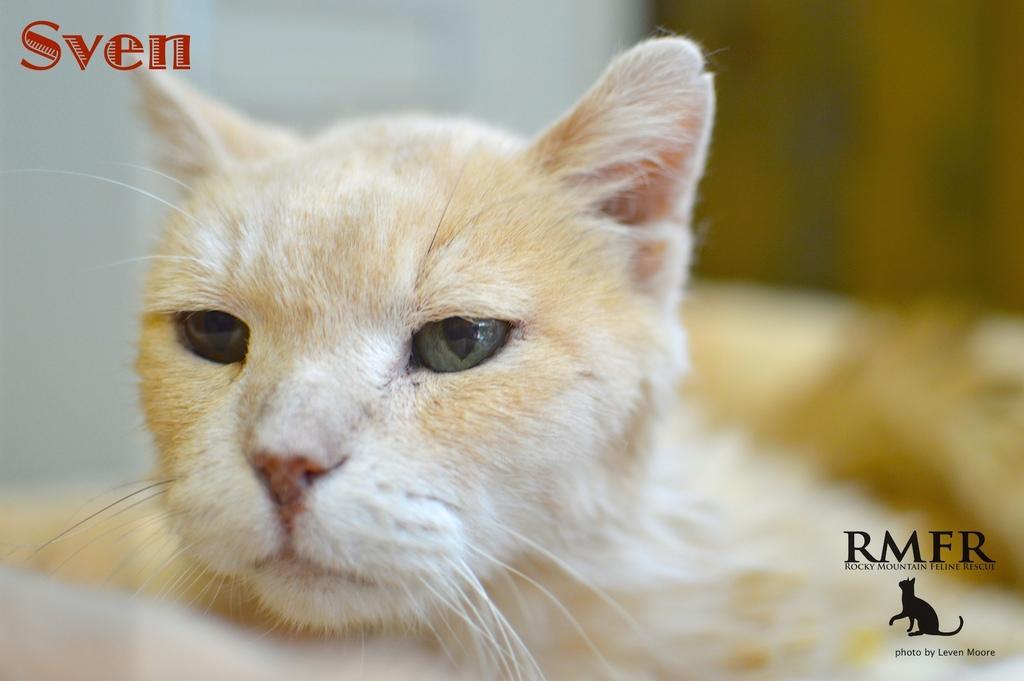How would you summarize this image in a sentence or two? In this image I can see a cream colour cat. On the top left corner and bottom right corner of this image I can see few watermarks. 